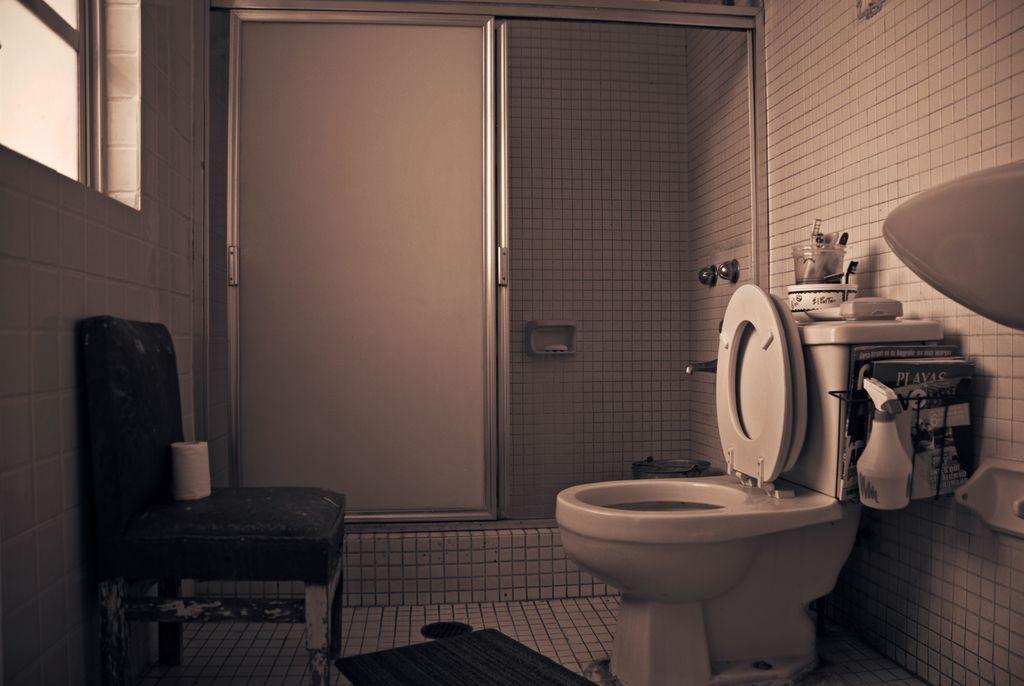In one or two sentences, can you explain what this image depicts? In this image I see a door, a toilet, a chair and the window. 